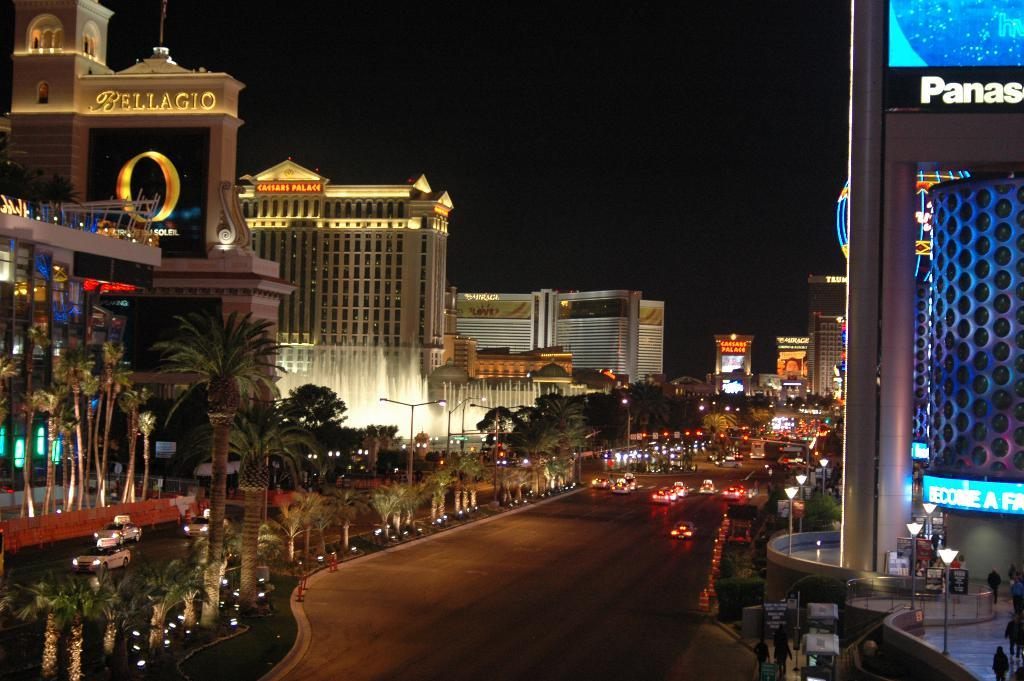<image>
Present a compact description of the photo's key features. A panoramic shot of a vibrant street in Las Vegas featuring the Pallgio. 